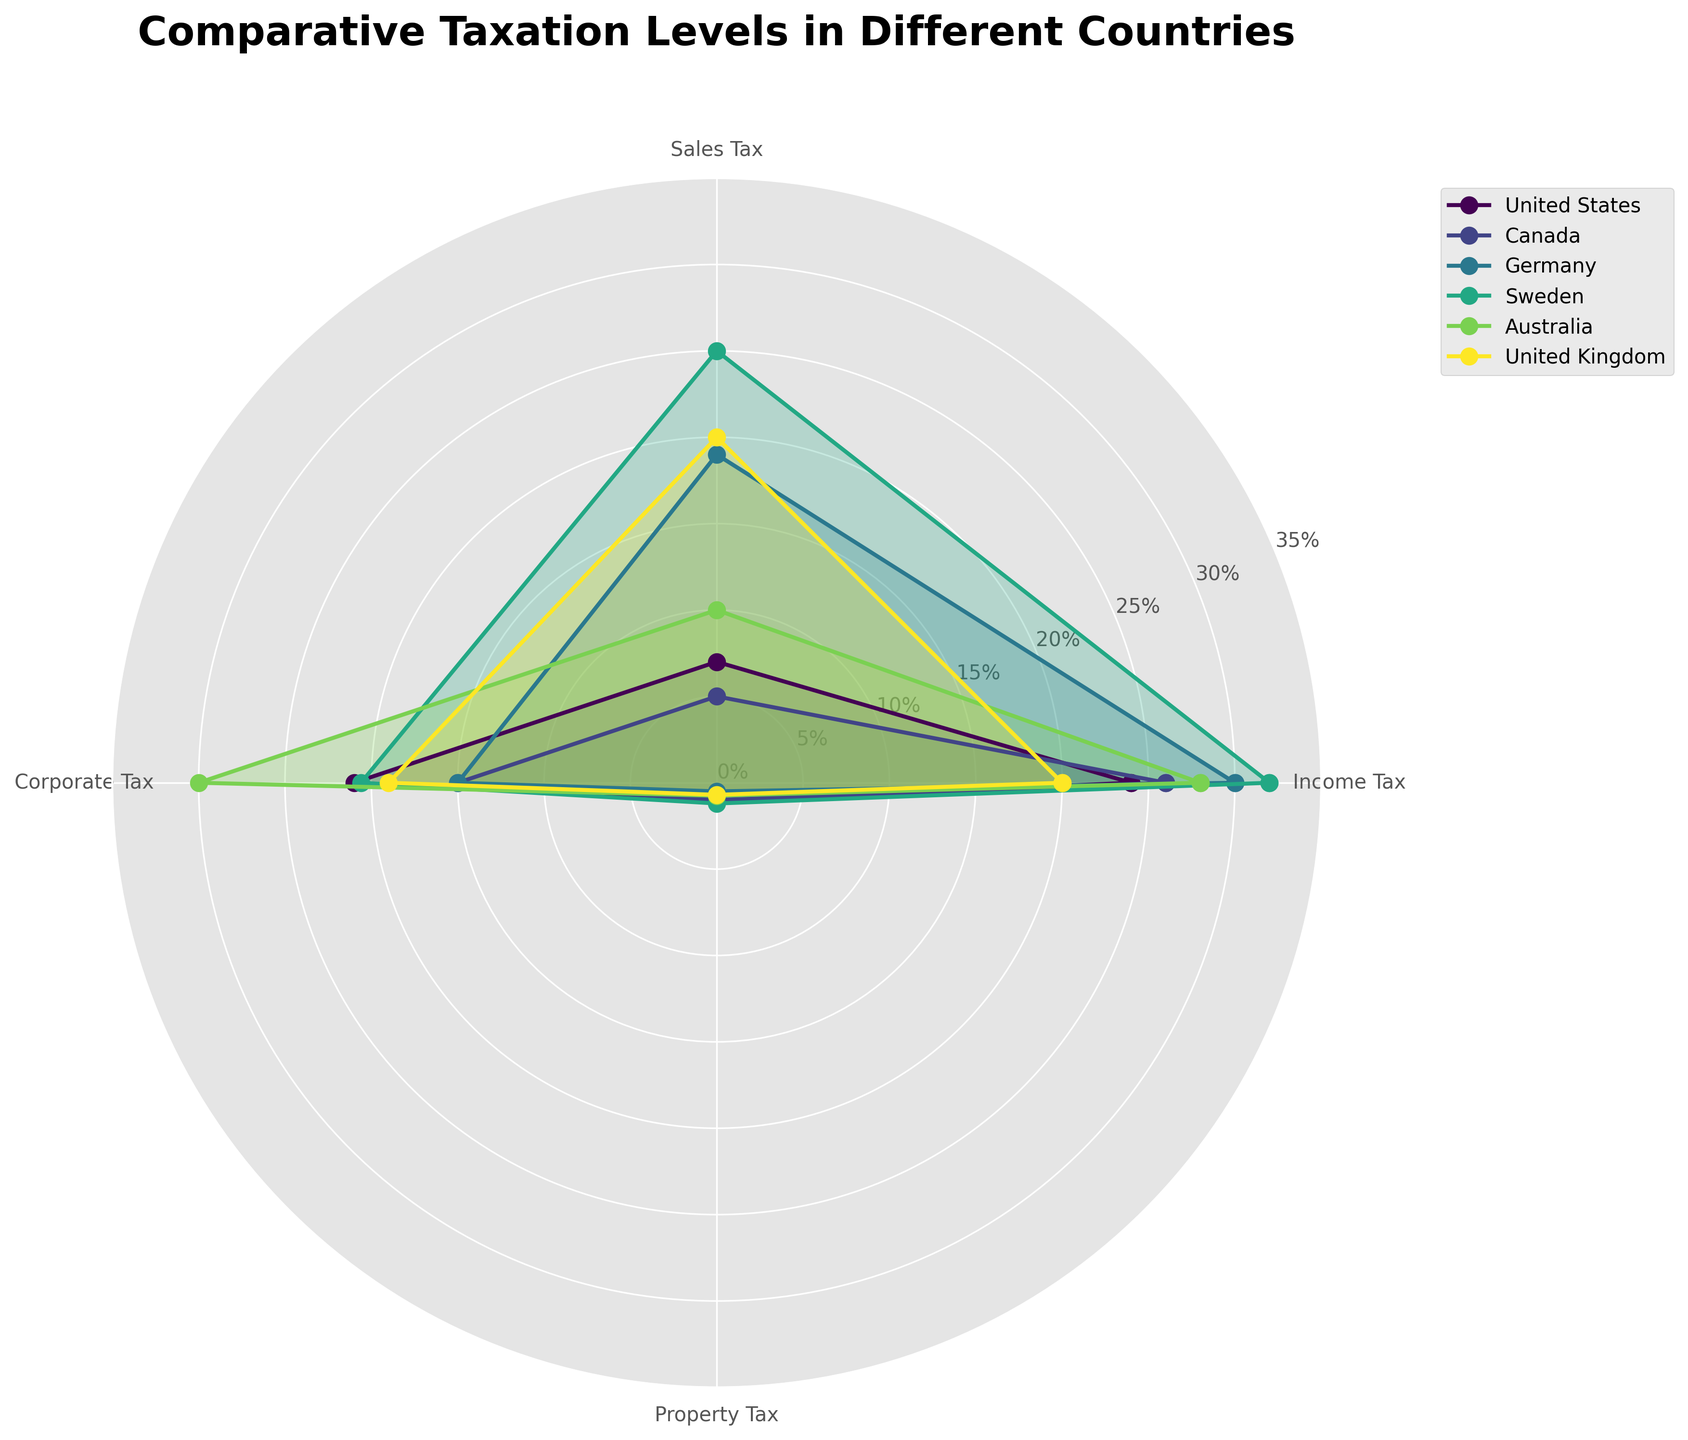What is the title of the chart? The title is written at the top of the chart in bold letters. It provides a clear indication of what the chart represents.
Answer: Comparative Taxation Levels in Different Countries How many countries are represented in the chart? Count the different colored filled areas or the number of labels in the legend, each representing a different country.
Answer: 6 Which country has the highest Income Tax rate? Look for the country with the longest segment for Income Tax. By comparing the lengths, we can see that the country with the longest Income Tax segment is the one with the highest rate.
Answer: Sweden Out of the listed countries, which one has the lowest Property Tax rate? Identify the smallest segment for Property Tax by comparing the lengths in the chart, focusing specifically on the Property Tax labels.
Answer: Germany For the United States, what is the difference between the Corporate Tax rate and the Income Tax rate? Locate the lengths of both the Income Tax (24) and Corporate Tax (21) segments for the United States and subtract the Corporate Tax rate from the Income Tax rate.
Answer: 3 How do the Sales Tax rates between Canada and Australia compare? Look for the Sales Tax segments for both Canada and Australia and compare their lengths. Canada has 5, and Australia has 10, so Australia’s Sales Tax is higher.
Answer: Australia's Sales Tax rate is higher than Canada's Which tax type has the most varied rates across all countries? To determine this, analyze each tax type individually and assess the variability in segment lengths across different countries. The tax type with the most noticeable difference in segment lengths indicates the most variability.
Answer: Sales Tax On average, which country has the highest tax rates across all four tax types? Calculate the average tax rate for each country by summing the rates of Income Tax, Sales Tax, Corporate Tax, and Property Tax, then divide by 4 to find the average. Compare these averages to determine the highest one.
Answer: Sweden Which country has the highest total taxation rate when summing all four tax types? Sum the four tax types for each country and determine which country has the highest total sum.
Answer: United States What is the difference between the highest and lowest Corporate Tax rates shown in the chart? Identify the highest and lowest Corporate Tax rates from the segments, which are 30 (Australia) and 15 (Canada and Germany), and subtract the lowest from the highest.
Answer: 15 